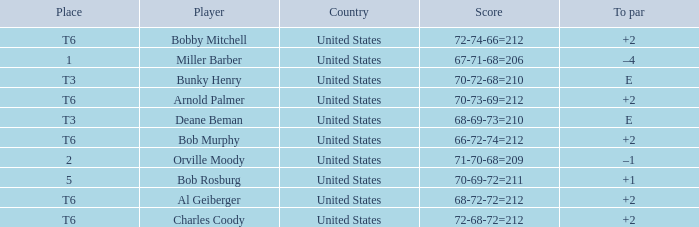What is the score of player bob rosburg? 70-69-72=211. 